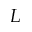Convert formula to latex. <formula><loc_0><loc_0><loc_500><loc_500>L</formula> 